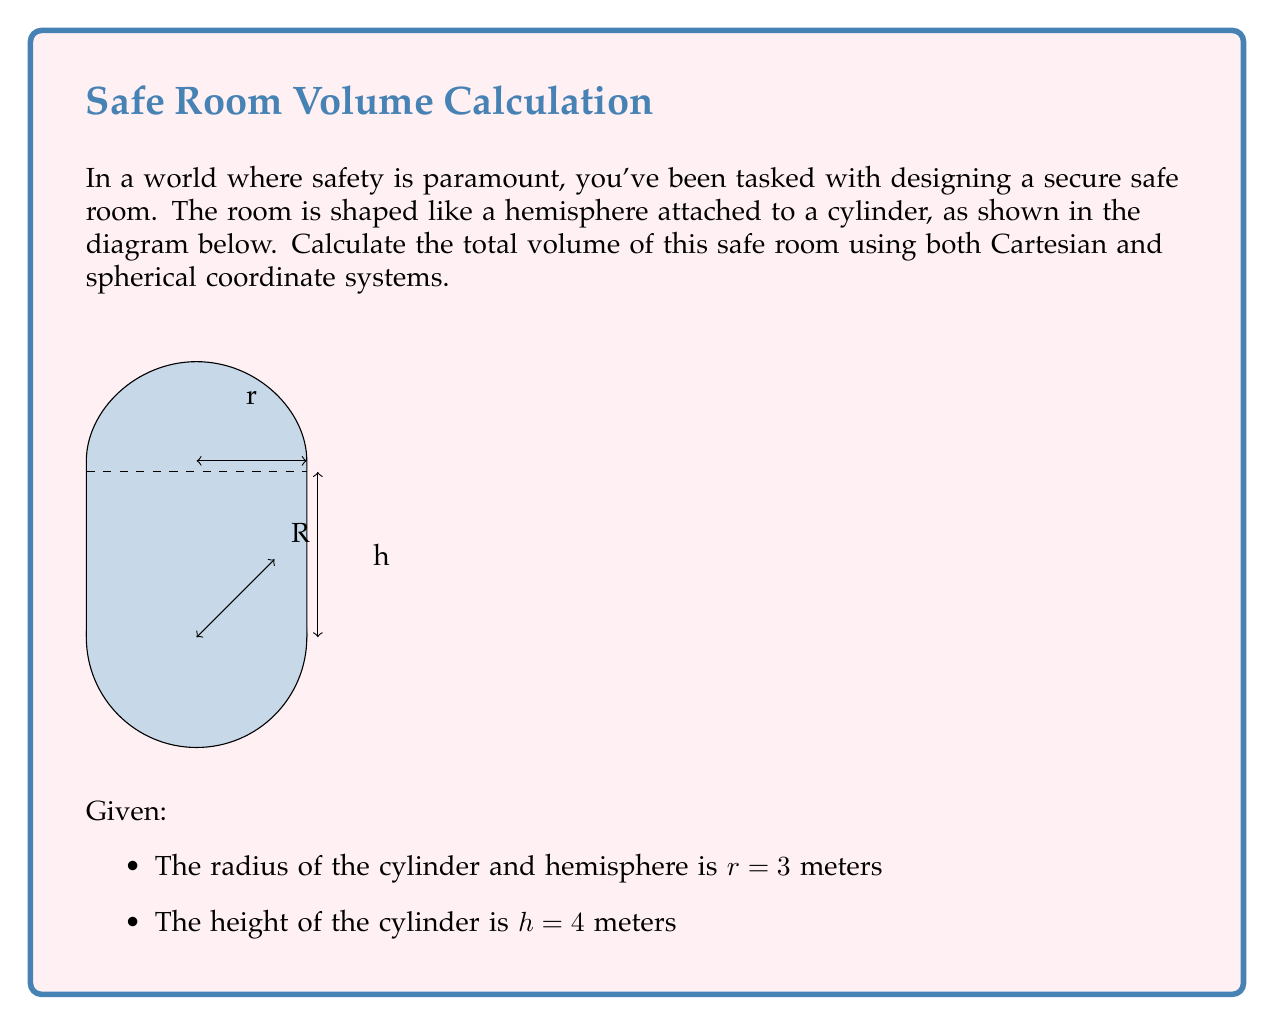Could you help me with this problem? Let's approach this problem step-by-step using both coordinate systems:

1. Cartesian Coordinate System:

a) Volume of cylinder:
   $$V_{cylinder} = \pi r^2 h = \pi (3^2)(4) = 36\pi \text{ m}^3$$

b) Volume of hemisphere:
   $$V_{hemisphere} = \frac{2}{3}\pi r^3 = \frac{2}{3}\pi (3^3) = 18\pi \text{ m}^3$$

c) Total volume:
   $$V_{total} = V_{cylinder} + V_{hemisphere} = 36\pi + 18\pi = 54\pi \text{ m}^3$$

2. Spherical Coordinate System:

a) Volume of cylinder:
   $$V_{cylinder} = \int_0^{2\pi} \int_0^r \int_0^h \rho d\rho d\theta dz = 2\pi \int_0^r \int_0^h \rho d\rho dz = \pi r^2 h = 36\pi \text{ m}^3$$

b) Volume of hemisphere:
   $$V_{hemisphere} = \int_0^{2\pi} \int_0^{\pi/2} \int_0^r \rho^2 \sin\phi d\rho d\phi d\theta = \frac{2}{3}\pi r^3 = 18\pi \text{ m}^3$$

c) Total volume:
   $$V_{total} = V_{cylinder} + V_{hemisphere} = 36\pi + 18\pi = 54\pi \text{ m}^3$$

Both coordinate systems yield the same result, confirming our calculation.
Answer: $54\pi \text{ m}^3$ 